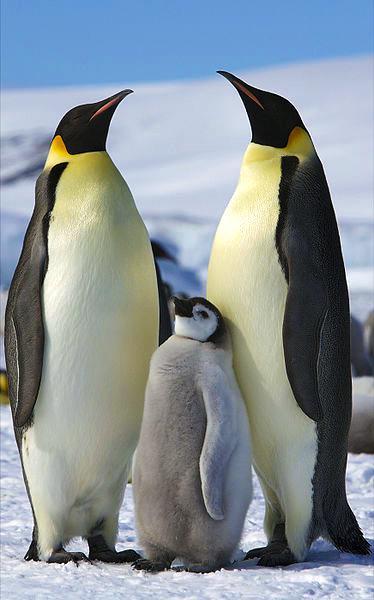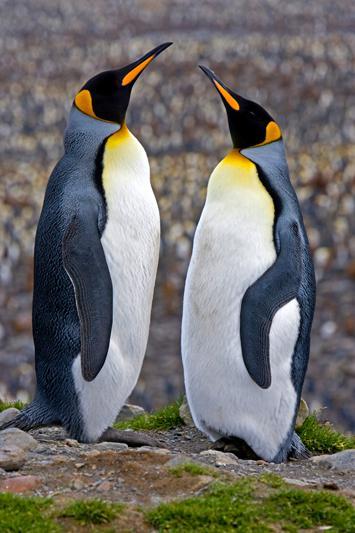The first image is the image on the left, the second image is the image on the right. Given the left and right images, does the statement "There are five penguins" hold true? Answer yes or no. Yes. 